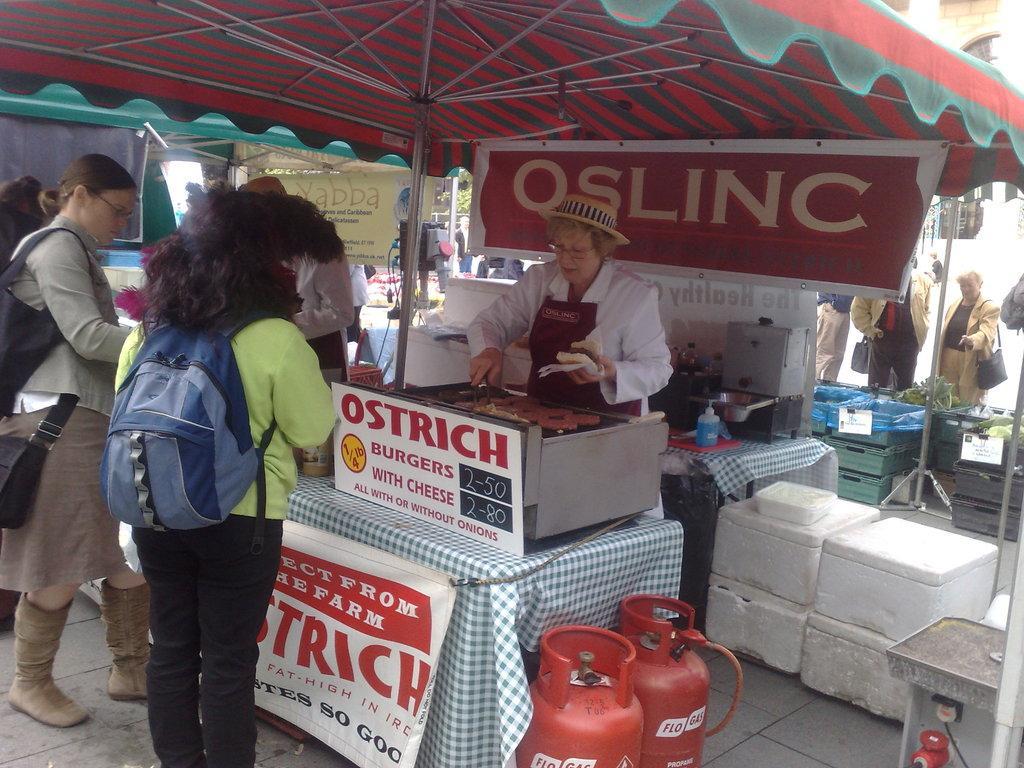Can you describe this image briefly? This picture describes about group of people, few people are standing under the tent, and a woman is cooking, beside to her we can see few cylinders, in the left side of the image we can find a woman, she wore a backpack,, in the background we can find few hoardings and baskets. 